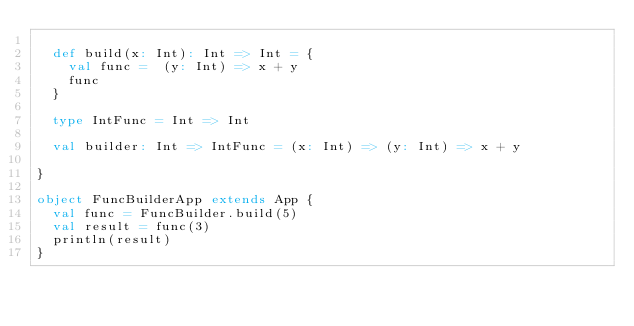<code> <loc_0><loc_0><loc_500><loc_500><_Scala_>
  def build(x: Int): Int => Int = {
    val func =  (y: Int) => x + y
    func
  }

  type IntFunc = Int => Int

  val builder: Int => IntFunc = (x: Int) => (y: Int) => x + y

}

object FuncBuilderApp extends App {
  val func = FuncBuilder.build(5)
  val result = func(3)
  println(result)
}</code> 